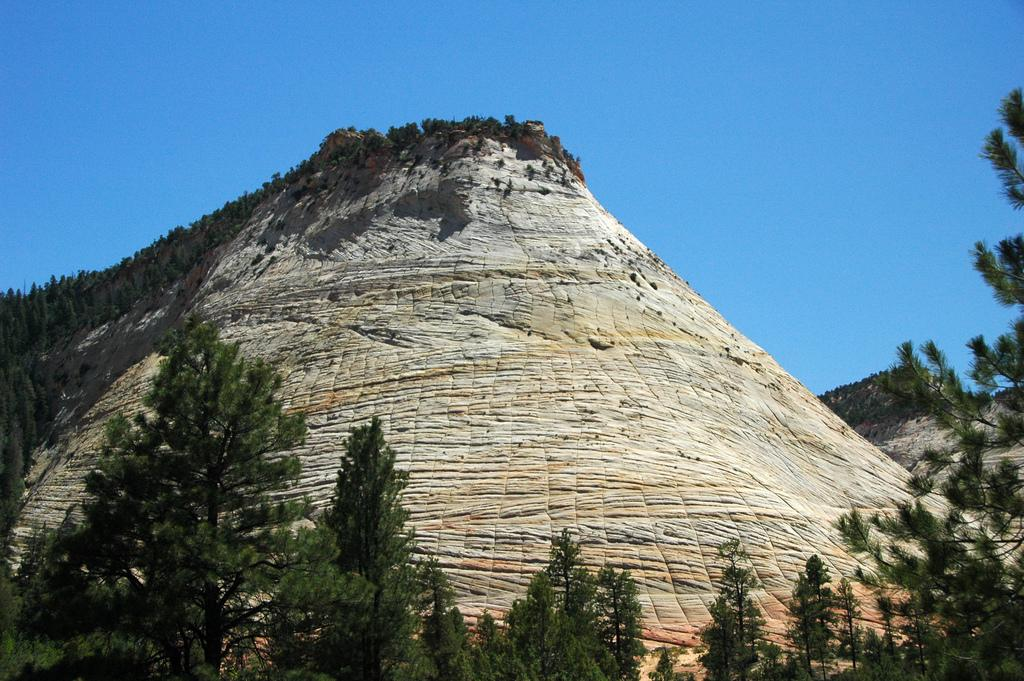What is the main subject of the image? The main subject of the image is a rock formation. Can you describe the size of the rock formation? The rock formation is very huge. What else can be seen in the image besides the rock formation? There are many trees around the rock formation. What type of currency is being exchanged in the image? There is no exchange of currency or any indication of a transaction in the image; it features a rock formation and trees. 